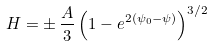Convert formula to latex. <formula><loc_0><loc_0><loc_500><loc_500>H = \pm \, { \frac { A } { 3 } } \left ( 1 - e ^ { 2 ( \psi _ { 0 } - \psi ) } \right ) ^ { 3 / 2 }</formula> 